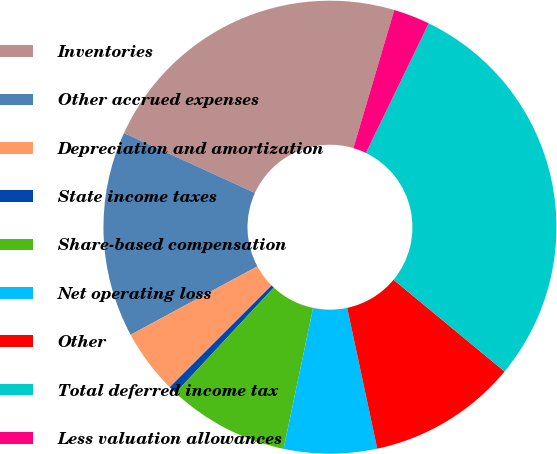Convert chart. <chart><loc_0><loc_0><loc_500><loc_500><pie_chart><fcel>Inventories<fcel>Other accrued expenses<fcel>Depreciation and amortization<fcel>State income taxes<fcel>Share-based compensation<fcel>Net operating loss<fcel>Other<fcel>Total deferred income tax<fcel>Less valuation allowances<nl><fcel>22.76%<fcel>14.7%<fcel>4.61%<fcel>0.58%<fcel>8.65%<fcel>6.63%<fcel>10.66%<fcel>28.81%<fcel>2.6%<nl></chart> 